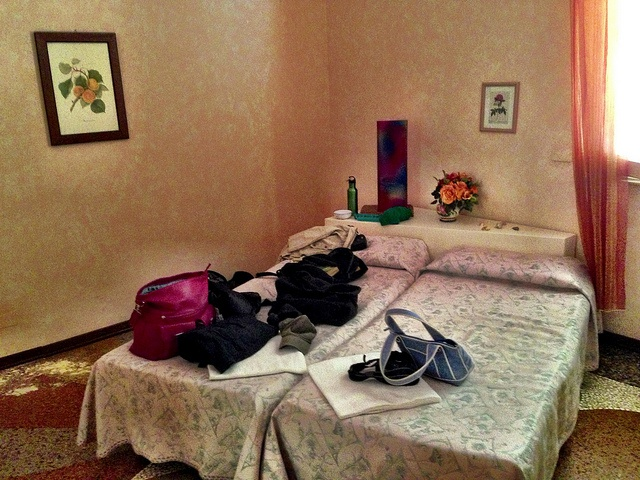Describe the objects in this image and their specific colors. I can see bed in tan, darkgray, gray, and lightgray tones, bed in tan, gray, and brown tones, handbag in tan, maroon, black, purple, and brown tones, handbag in tan, black, gray, and darkgray tones, and potted plant in tan, black, maroon, and gray tones in this image. 